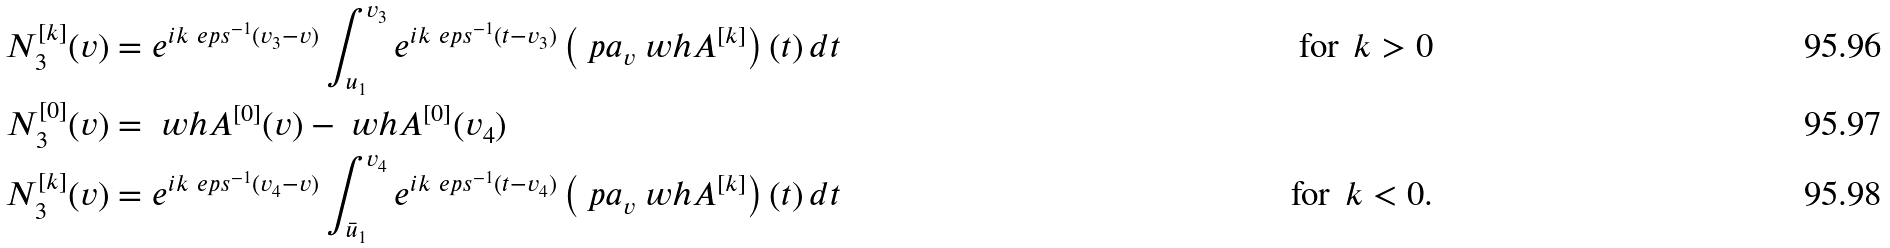<formula> <loc_0><loc_0><loc_500><loc_500>N _ { 3 } ^ { [ k ] } ( v ) & = e ^ { i k \ e p s ^ { - 1 } ( v _ { 3 } - v ) } \int _ { u _ { 1 } } ^ { v _ { 3 } } e ^ { i k \ e p s ^ { - 1 } ( t - v _ { 3 } ) } \left ( \ p a _ { v } \ w h A ^ { [ k ] } \right ) ( t ) \, d t & \text {for } \, k > 0 \\ N _ { 3 } ^ { [ 0 ] } ( v ) & = \ w h A ^ { [ 0 ] } ( v ) - \ w h A ^ { [ 0 ] } ( v _ { 4 } ) \\ N _ { 3 } ^ { [ k ] } ( v ) & = e ^ { i k \ e p s ^ { - 1 } ( v _ { 4 } - v ) } \int _ { \bar { u } _ { 1 } } ^ { v _ { 4 } } e ^ { i k \ e p s ^ { - 1 } ( t - v _ { 4 } ) } \left ( \ p a _ { v } \ w h A ^ { [ k ] } \right ) ( t ) \, d t & \text {for } \, k < 0 .</formula> 